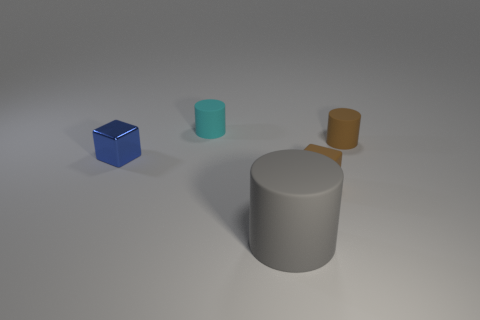Are there any other things of the same color as the tiny metal thing?
Offer a very short reply. No. Is the material of the cyan thing the same as the blue block?
Your response must be concise. No. There is a tiny cylinder that is to the right of the thing behind the brown cylinder; what number of tiny blue metallic blocks are to the right of it?
Provide a succinct answer. 0. What number of cyan objects are there?
Make the answer very short. 1. Is the number of large gray rubber cylinders on the right side of the big cylinder less than the number of large gray matte cylinders behind the rubber cube?
Offer a very short reply. No. Is the number of cubes that are in front of the tiny blue shiny cube less than the number of small things?
Provide a succinct answer. Yes. What material is the cube behind the block in front of the block left of the gray rubber cylinder?
Ensure brevity in your answer.  Metal. What number of things are either things that are in front of the cyan thing or tiny cylinders to the right of the cyan rubber cylinder?
Your answer should be very brief. 4. How many metallic objects are cyan cylinders or brown cubes?
Your response must be concise. 0. What shape is the small brown object that is made of the same material as the tiny brown cylinder?
Your answer should be compact. Cube. 